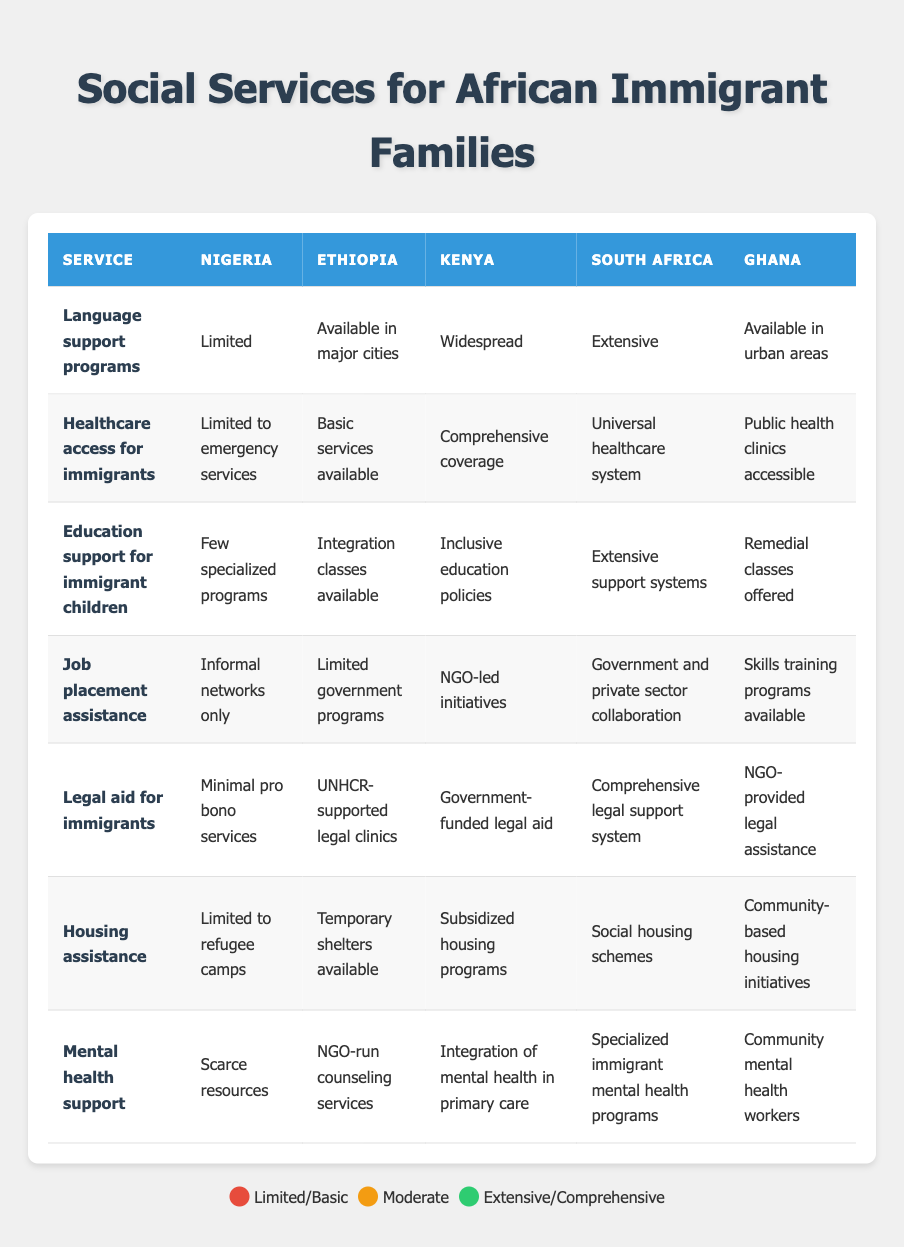What social service has the most extensive support in South Africa? In South Africa, the service with the most extensive support is the "Universal healthcare system" for healthcare access, while "Comprehensive legal support system" is also noted for legal aid. However, for a focused answer among services, "Comprehensive legal support system" is most prominent in overall representation.
Answer: Comprehensive legal support system Which African country provides limited housing assistance for immigrants? Referring to the table, Nigeria provides limited housing assistance, specifically stated as "Limited to refugee camps."
Answer: Nigeria Is mental health support for immigrants available in Kenya? In the table, Kenya has the entry "Integration of mental health in primary care," indicating that some level of mental health support is available.
Answer: Yes What is the difference in language support programs between Kenya and Nigeria? According to the table, Kenya has "Widespread" language support programs, while Nigeria is listed as having "Limited" support. Therefore, Kenya offers more resources compared to Nigeria, highlighting at least a moderate increase in support availability.
Answer: Widespread - Limited Which country offers the most comprehensive healthcare access for immigrants? The table shows that South Africa provides a "Universal healthcare system," which is the best-rated healthcare access for immigrants compared to other countries listed.
Answer: South Africa Is there any country that offers temporary shelters as the only form of housing assistance? The table states that Ethiopia has "Temporary shelters available," but it is not the sole form of housing assistance offered by other countries. Hence, yes, Ethiopia is the only one mentioned exclusively for this purpose.
Answer: Yes How many countries provide extensive education support for immigrant children? Looking at the table, both Kenya and South Africa are noted for extensive education support, with Kenya offering "Inclusive education policies" and South Africa having "Extensive support systems." Therefore, there are two countries with extensive education support.
Answer: Two What type of job placement assistance is provided in Ghana? The table indicates that Ghana offers "Skills training programs available" for job placement assistance, which means resources are directed towards enhancing the skills of immigrants for employment.
Answer: Skills training programs available Which country has the least resources for mental health support? Nigeria is marked as having "Scarce resources" for mental health support, which identifies it as having the least resources among the countries listed.
Answer: Nigeria 